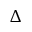Convert formula to latex. <formula><loc_0><loc_0><loc_500><loc_500>\Delta</formula> 